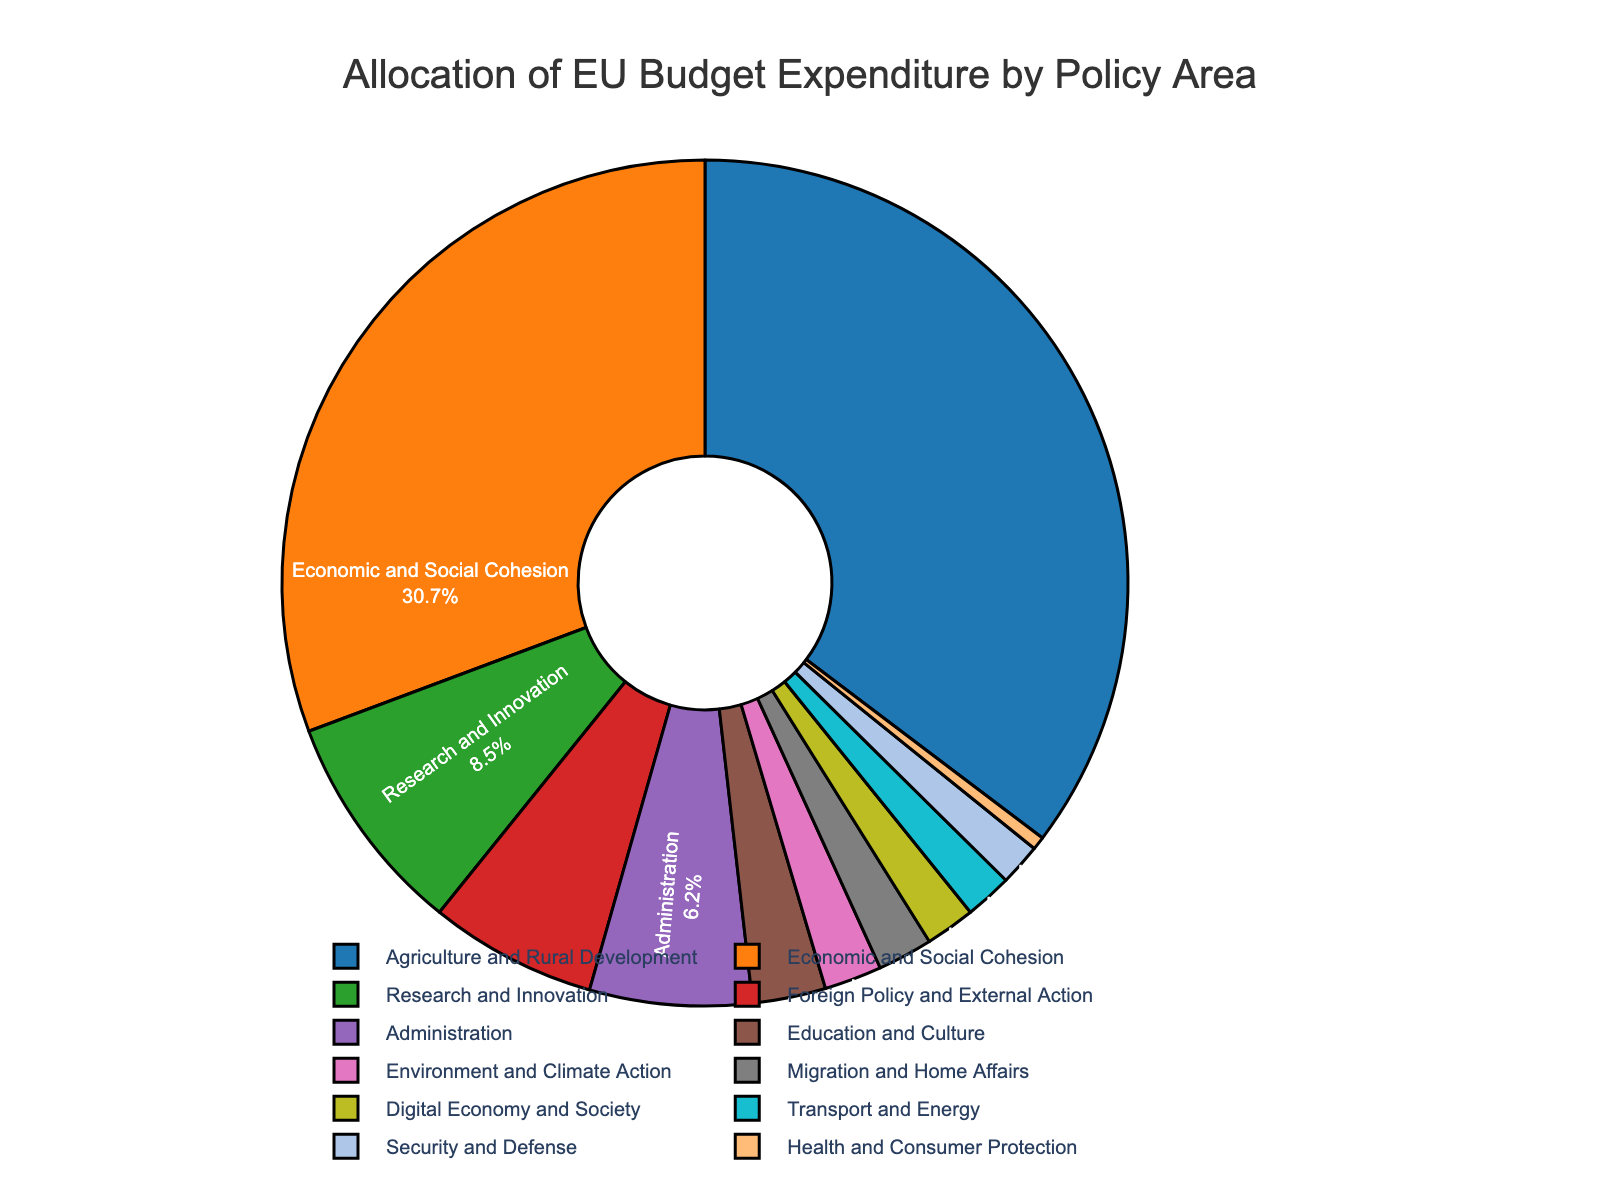Which policy area receives the largest allocation of the EU budget? Look at the pie chart and identify the segment with the highest percentage value.
Answer: Agriculture and Rural Development What is the combined percentage allocation for Education and Culture, Environment and Climate Action, and Migration and Home Affairs? Sum the percentages for the three policy areas: 2.8% (Education and Culture) + 2.2% (Environment and Climate Action) + 2.1% (Migration and Home Affairs) = 7.1%
Answer: 7.1% Which policy area has a larger budget allocation: Foreign Policy and External Action or Administration? Compare the percentages of Foreign Policy and External Action (6.4%) and Administration (6.2%) to see which one is greater.
Answer: Foreign Policy and External Action What is the percentage difference between Economic and Social Cohesion and Research and Innovation? Subtract the percentage of Research and Innovation (8.5%) from the percentage of Economic and Social Cohesion (30.7%): 30.7% - 8.5% = 22.2%
Answer: 22.2% How does the budget allocation for Security and Defense compare to that for Transport and Energy? Compare the percentages of Security and Defense (1.6%) and Transport and Energy (1.8%) to see which is higher.
Answer: Transport and Energy What is the average budget allocation percentage for the three largest policy areas? Calculate the average of the percentages of the three largest policy areas: (35.3% + 30.7% + 8.5%) / 3 = 24.8333...%
Answer: 24.8% Which policy area has the smallest budget allocation and what is its percentage? Look at the pie chart and identify the segment with the smallest percentage value.
Answer: Health and Consumer Protection, 0.5% How many policy areas have a budget allocation percentage that is less than 5%? Count the segments in the pie chart whose percentages are below 5%.
Answer: 6 